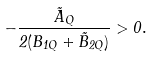<formula> <loc_0><loc_0><loc_500><loc_500>- \frac { \tilde { A } _ { Q } } { 2 ( B _ { 1 Q } + \tilde { B } _ { 2 Q } ) } > 0 .</formula> 